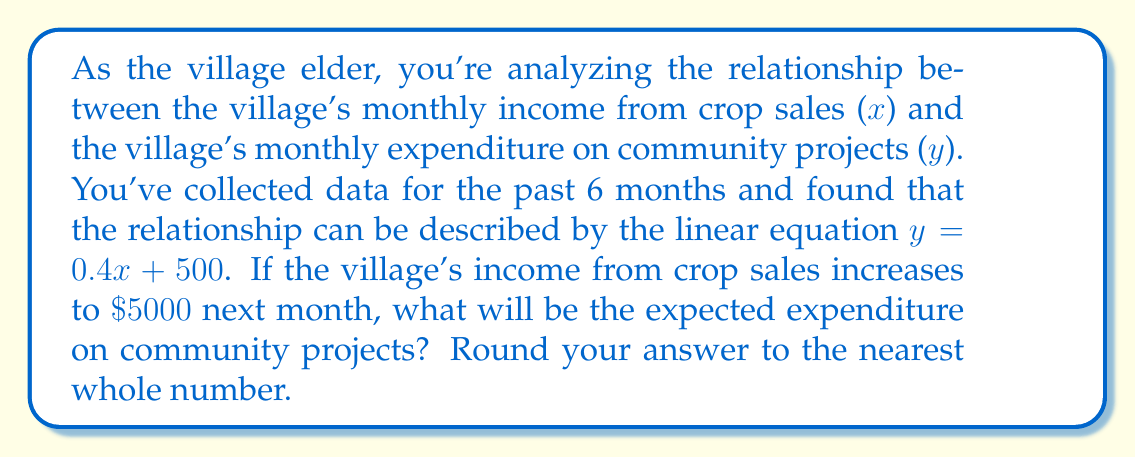Solve this math problem. To solve this problem, we'll use the given linear equation and follow these steps:

1) The linear equation is given as:
   $y = 0.4x + 500$

   Where:
   $y$ = monthly expenditure on community projects
   $x$ = monthly income from crop sales

2) We're told that next month's income from crop sales will be $5000. So we substitute $x = 5000$ into our equation:

   $y = 0.4(5000) + 500$

3) Let's solve this step-by-step:
   
   $y = 2000 + 500$
   $y = 2500$

4) The question asks to round to the nearest whole number, but 2500 is already a whole number, so no rounding is necessary.

Therefore, if the village's income from crop sales increases to $5000, the expected expenditure on community projects will be $2500.
Answer: $2500 